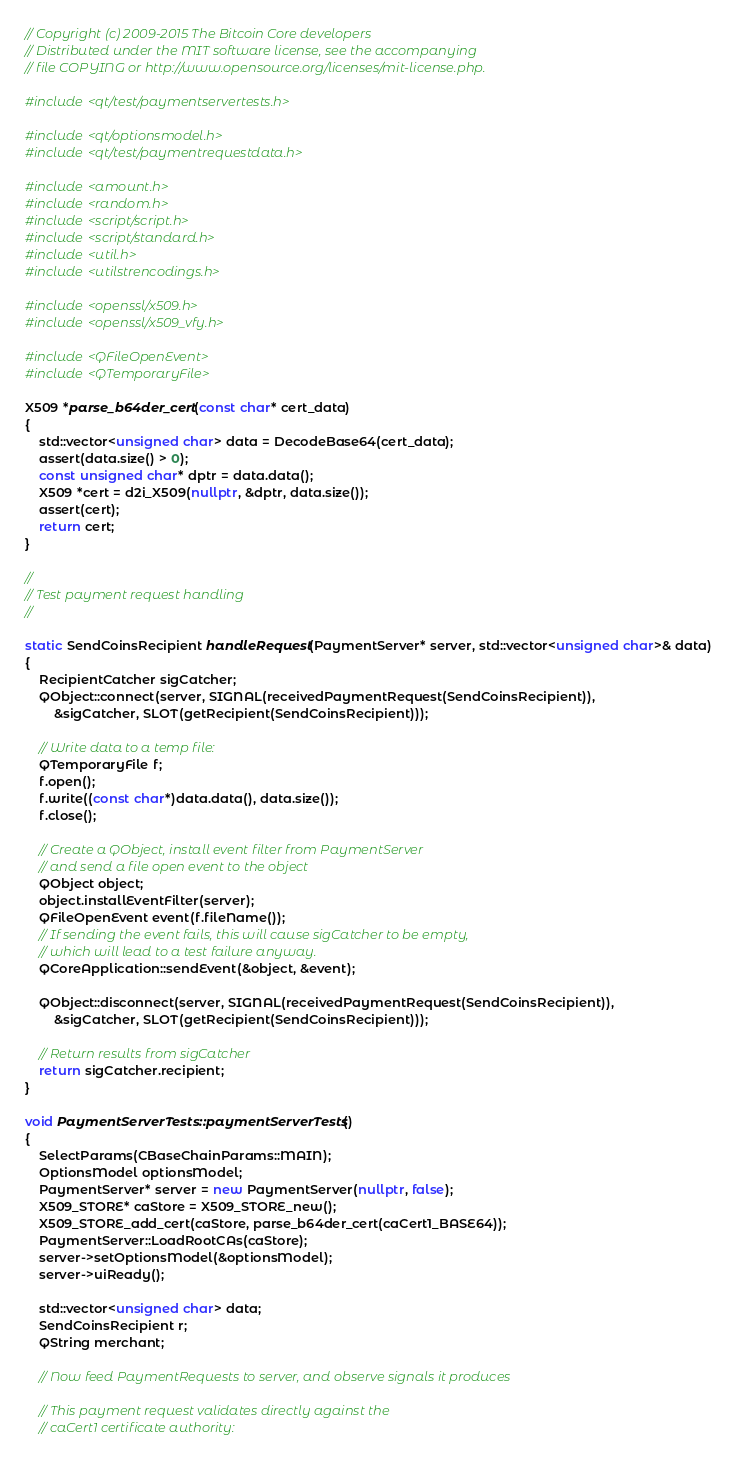Convert code to text. <code><loc_0><loc_0><loc_500><loc_500><_C++_>// Copyright (c) 2009-2015 The Bitcoin Core developers
// Distributed under the MIT software license, see the accompanying
// file COPYING or http://www.opensource.org/licenses/mit-license.php.

#include <qt/test/paymentservertests.h>

#include <qt/optionsmodel.h>
#include <qt/test/paymentrequestdata.h>

#include <amount.h>
#include <random.h>
#include <script/script.h>
#include <script/standard.h>
#include <util.h>
#include <utilstrencodings.h>

#include <openssl/x509.h>
#include <openssl/x509_vfy.h>

#include <QFileOpenEvent>
#include <QTemporaryFile>

X509 *parse_b64der_cert(const char* cert_data)
{
    std::vector<unsigned char> data = DecodeBase64(cert_data);
    assert(data.size() > 0);
    const unsigned char* dptr = data.data();
    X509 *cert = d2i_X509(nullptr, &dptr, data.size());
    assert(cert);
    return cert;
}

//
// Test payment request handling
//

static SendCoinsRecipient handleRequest(PaymentServer* server, std::vector<unsigned char>& data)
{
    RecipientCatcher sigCatcher;
    QObject::connect(server, SIGNAL(receivedPaymentRequest(SendCoinsRecipient)),
        &sigCatcher, SLOT(getRecipient(SendCoinsRecipient)));

    // Write data to a temp file:
    QTemporaryFile f;
    f.open();
    f.write((const char*)data.data(), data.size());
    f.close();

    // Create a QObject, install event filter from PaymentServer
    // and send a file open event to the object
    QObject object;
    object.installEventFilter(server);
    QFileOpenEvent event(f.fileName());
    // If sending the event fails, this will cause sigCatcher to be empty,
    // which will lead to a test failure anyway.
    QCoreApplication::sendEvent(&object, &event);

    QObject::disconnect(server, SIGNAL(receivedPaymentRequest(SendCoinsRecipient)),
        &sigCatcher, SLOT(getRecipient(SendCoinsRecipient)));

    // Return results from sigCatcher
    return sigCatcher.recipient;
}

void PaymentServerTests::paymentServerTests()
{
    SelectParams(CBaseChainParams::MAIN);
    OptionsModel optionsModel;
    PaymentServer* server = new PaymentServer(nullptr, false);
    X509_STORE* caStore = X509_STORE_new();
    X509_STORE_add_cert(caStore, parse_b64der_cert(caCert1_BASE64));
    PaymentServer::LoadRootCAs(caStore);
    server->setOptionsModel(&optionsModel);
    server->uiReady();

    std::vector<unsigned char> data;
    SendCoinsRecipient r;
    QString merchant;

    // Now feed PaymentRequests to server, and observe signals it produces

    // This payment request validates directly against the
    // caCert1 certificate authority:</code> 